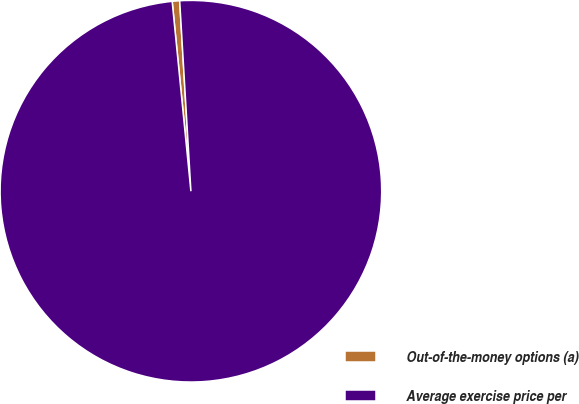Convert chart. <chart><loc_0><loc_0><loc_500><loc_500><pie_chart><fcel>Out-of-the-money options (a)<fcel>Average exercise price per<nl><fcel>0.63%<fcel>99.37%<nl></chart> 